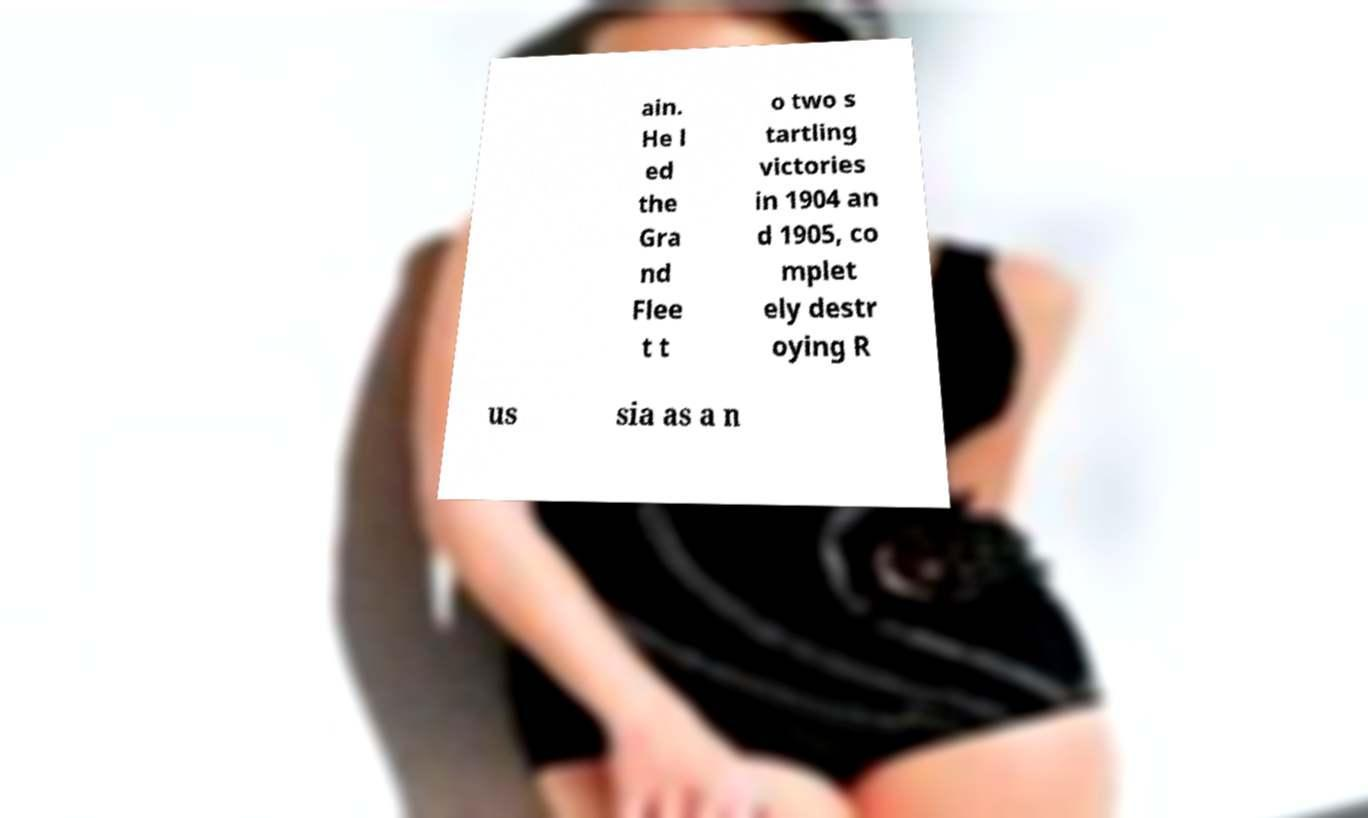Please read and relay the text visible in this image. What does it say? ain. He l ed the Gra nd Flee t t o two s tartling victories in 1904 an d 1905, co mplet ely destr oying R us sia as a n 